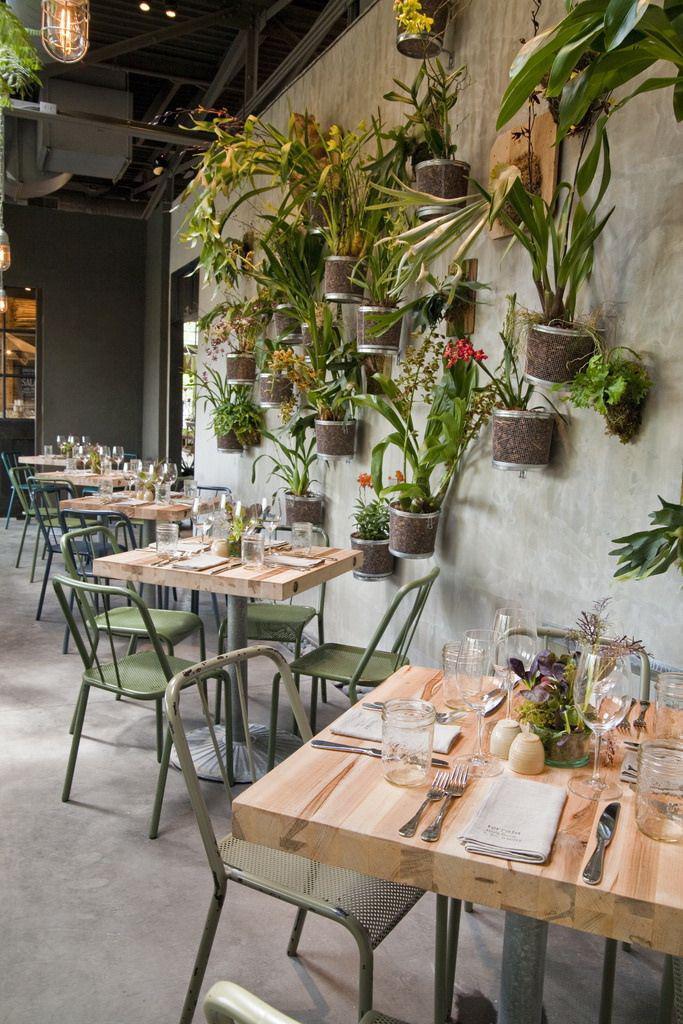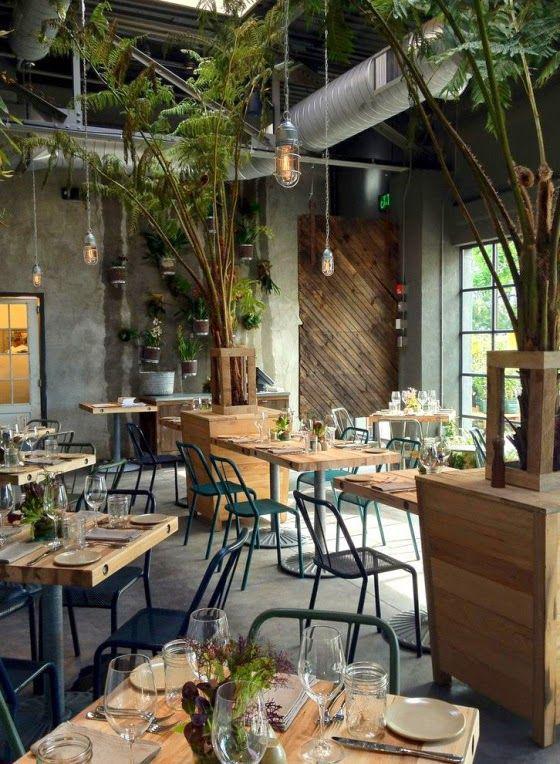The first image is the image on the left, the second image is the image on the right. For the images displayed, is the sentence "The left and right image each contain at least five square light brown wooden dining tables." factually correct? Answer yes or no. Yes. The first image is the image on the left, the second image is the image on the right. For the images shown, is this caption "At least one restaurant's tables are sitting outdoors in the open air." true? Answer yes or no. No. 